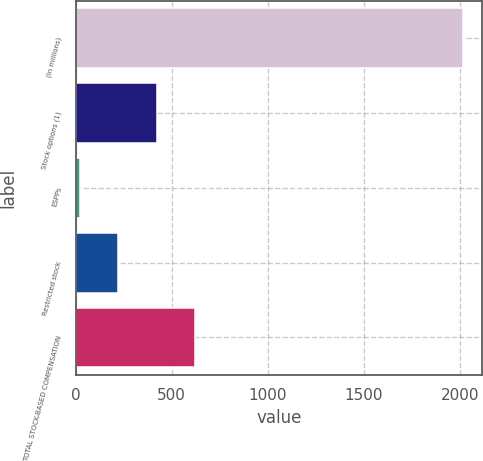Convert chart to OTSL. <chart><loc_0><loc_0><loc_500><loc_500><bar_chart><fcel>(In millions)<fcel>Stock options (1)<fcel>ESPPs<fcel>Restricted stock<fcel>TOTAL STOCK-BASED COMPENSATION<nl><fcel>2015<fcel>422.2<fcel>24<fcel>223.1<fcel>621.3<nl></chart> 